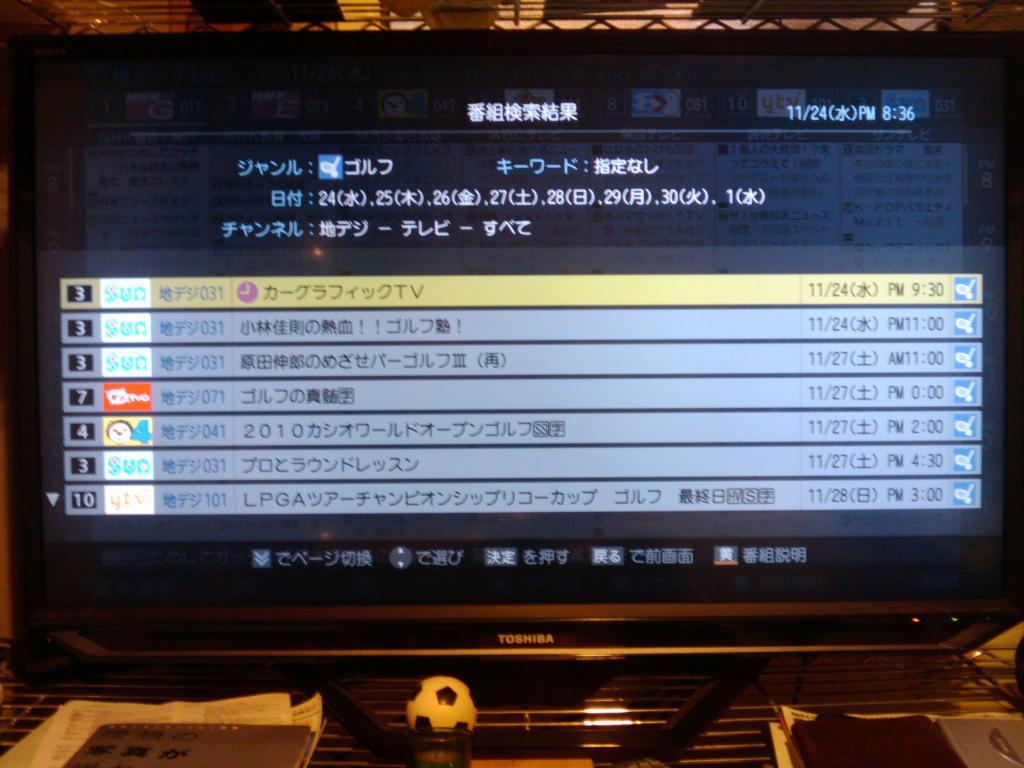<image>
Present a compact description of the photo's key features. A toshiba branded television with a selection of channels with text in japanese. 